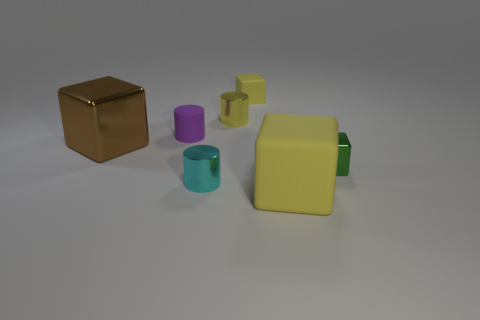Subtract all large yellow blocks. How many blocks are left? 3 Subtract all green balls. How many yellow blocks are left? 2 Add 2 tiny purple rubber cylinders. How many objects exist? 9 Subtract all green cubes. How many cubes are left? 3 Subtract all cylinders. How many objects are left? 4 Subtract all green cubes. Subtract all brown cylinders. How many cubes are left? 3 Subtract 0 cyan cubes. How many objects are left? 7 Subtract all large brown matte objects. Subtract all shiny cylinders. How many objects are left? 5 Add 4 tiny purple cylinders. How many tiny purple cylinders are left? 5 Add 4 small rubber cylinders. How many small rubber cylinders exist? 5 